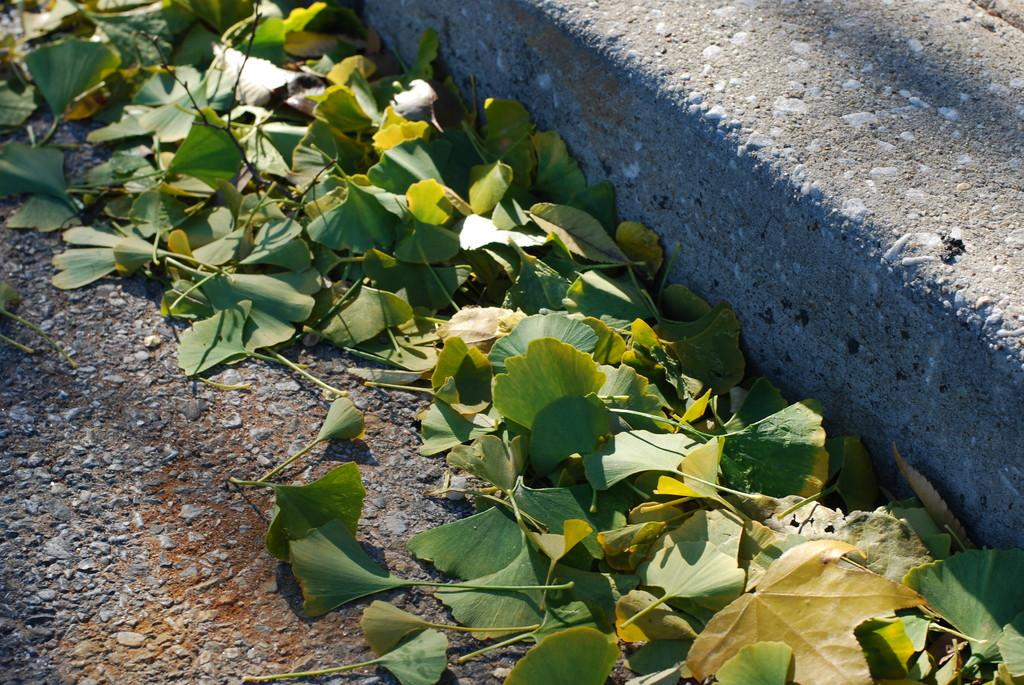What color are the leaves in the image? The leaves in the image are green. What is located at the bottom of the image? There is a road at the bottom of the image. What object can be seen on the right side of the image? There is a concrete block on the right side of the image. What might the concrete block be a part of? The concrete block appears to be part of a pavement. How many pizzas are being sorted by the father in the image? There are no pizzas or fathers present in the image. 